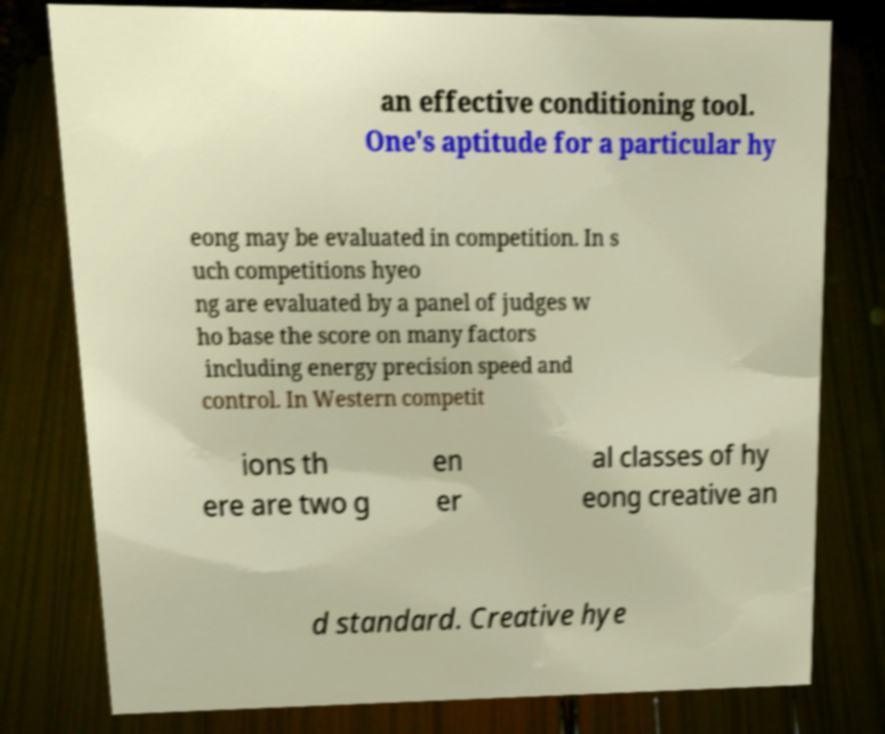What messages or text are displayed in this image? I need them in a readable, typed format. an effective conditioning tool. One's aptitude for a particular hy eong may be evaluated in competition. In s uch competitions hyeo ng are evaluated by a panel of judges w ho base the score on many factors including energy precision speed and control. In Western competit ions th ere are two g en er al classes of hy eong creative an d standard. Creative hye 